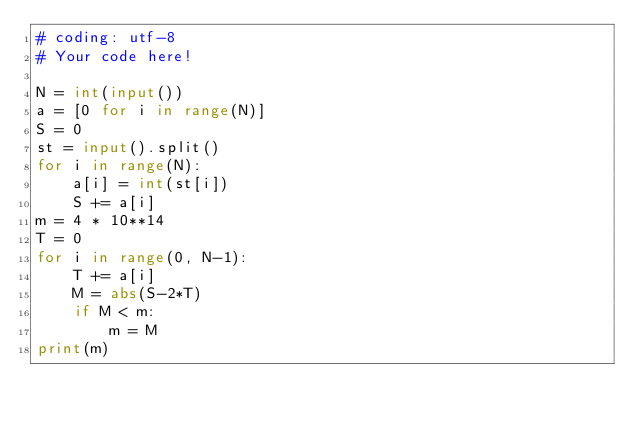Convert code to text. <code><loc_0><loc_0><loc_500><loc_500><_Python_># coding: utf-8
# Your code here!

N = int(input())
a = [0 for i in range(N)]
S = 0
st = input().split()
for i in range(N):
    a[i] = int(st[i])
    S += a[i]
m = 4 * 10**14
T = 0
for i in range(0, N-1):
    T += a[i]
    M = abs(S-2*T)
    if M < m:
        m = M
print(m)
</code> 